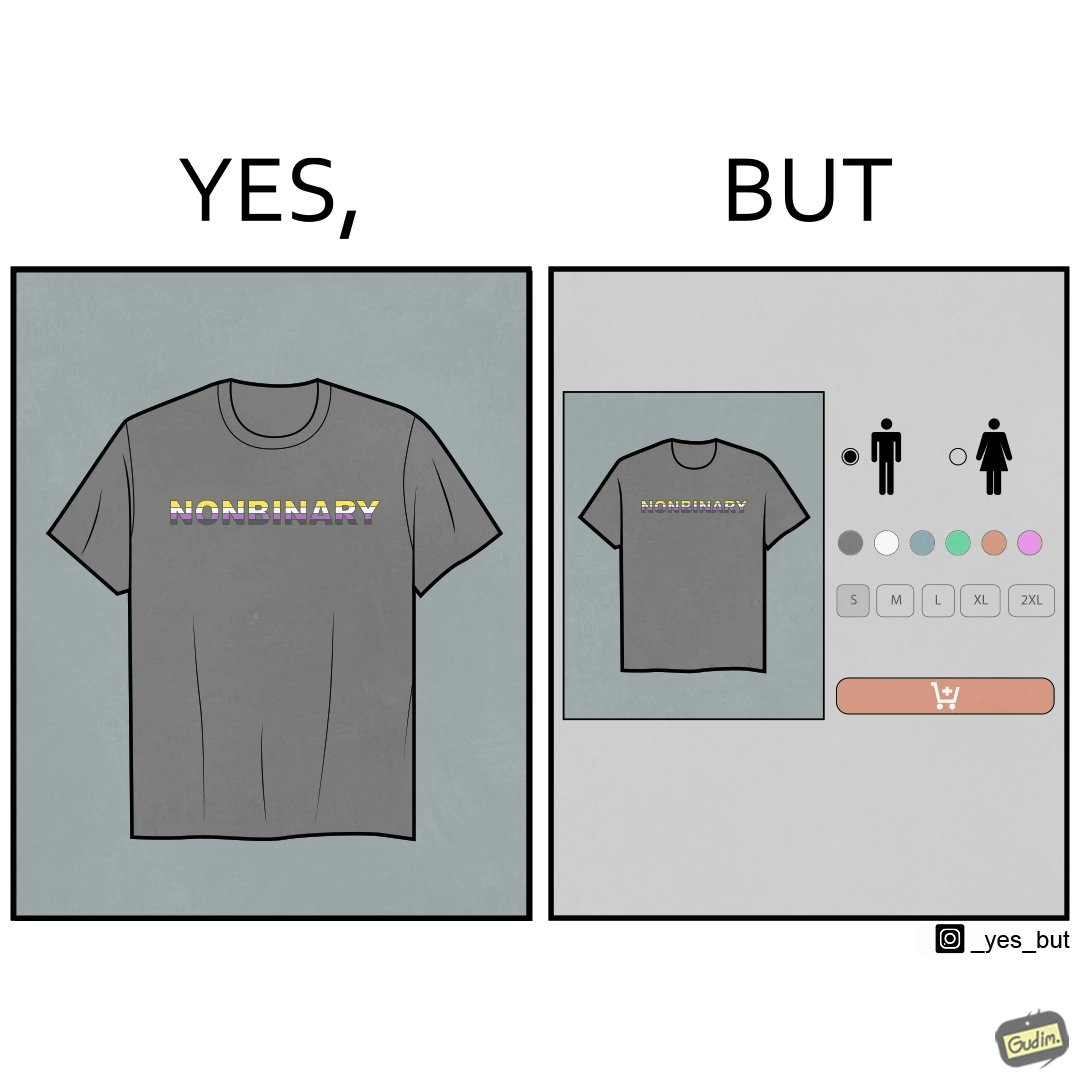What is shown in the left half versus the right half of this image? In the left part of the image: t-shirt with "NONBINARY" written on it. In the right part of the image: t-shirt with "NONBINARY" written on it, with several customizable options for color and 2 gender options on the right 